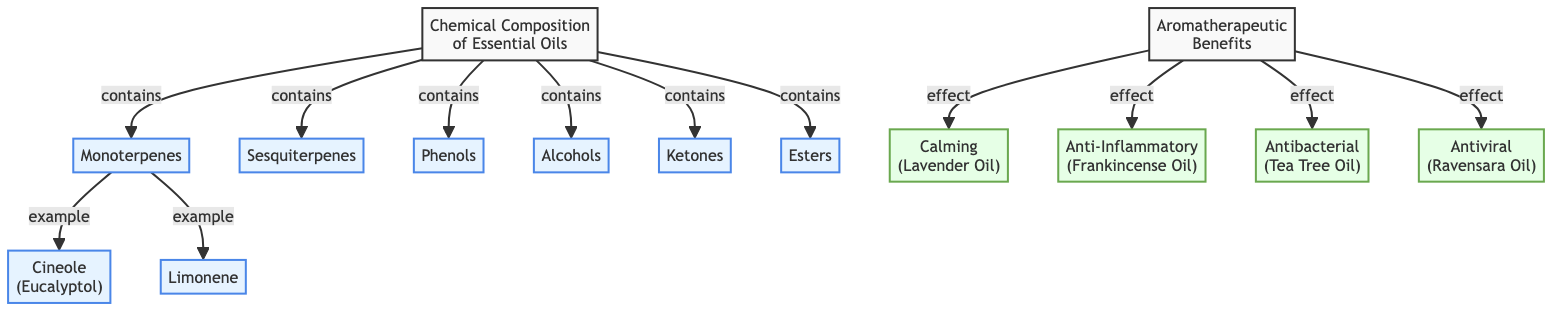What are the primary categories of chemical composition mentioned? The diagram lists six primary categories of chemical composition: Monoterpenes, Sesquiterpenes, Phenols, Alcohols, Ketones, and Esters. This information is located directly under the "Chemical Composition of Essential Oils" node, showing the relationships.
Answer: Monoterpenes, Sesquiterpenes, Phenols, Alcohols, Ketones, Esters Which essential oil is an example of Monoterpenes? The diagram presents two examples of Monoterpenes: Cineole (Eucalyptol) and Limonene. Both examples are connected to the Monoterpenes category, making it clear these oils fall under this classification.
Answer: Cineole (Eucalyptol), Limonene How many aromatherapeutic benefits are listed in the diagram? The diagram indicates four aromatherapeutic benefits: Calming, Anti-Inflammatory, Antibacterial, and Antiviral. These benefits are connected to the "Aromatherapeutic Benefits" node, showing a clear count from that connection.
Answer: 4 Which chemical composition is associated with Frankincense Oil? According to the diagram, Frankincense Oil is associated with the Anti-Inflammatory benefit. The diagram shows an effect relationship leading from Aromatherapeutic Benefits to Frankincense Oil, indicating this connection.
Answer: Anti-Inflammatory What is the relationship between Esters and aromatherapeutic benefits? The diagram does not show a direct relationship between Esters and any specific aromatherapeutic benefits, as Esters are listed under chemical composition but do not lead to any benefits in the flowchart. This indicates that their therapeutic application is not represented in the provided information.
Answer: No direct relationship What is the node that directly connects all chemical compositions? The node that directly connects all chemical compositions is "Chemical Composition of Essential Oils." This central node leads to all the identified categories of chemical compositions and illustrates their aggregated relevance.
Answer: Chemical Composition of Essential Oils 